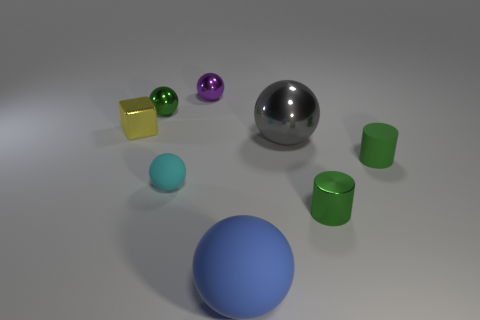Add 1 large blue spheres. How many objects exist? 9 Subtract all green balls. How many balls are left? 4 Subtract all cubes. How many objects are left? 7 Subtract all yellow spheres. Subtract all yellow cylinders. How many spheres are left? 5 Subtract all tiny purple metal objects. Subtract all big objects. How many objects are left? 5 Add 4 tiny purple objects. How many tiny purple objects are left? 5 Add 8 gray metal spheres. How many gray metal spheres exist? 9 Subtract all cyan spheres. How many spheres are left? 4 Subtract 1 cyan balls. How many objects are left? 7 